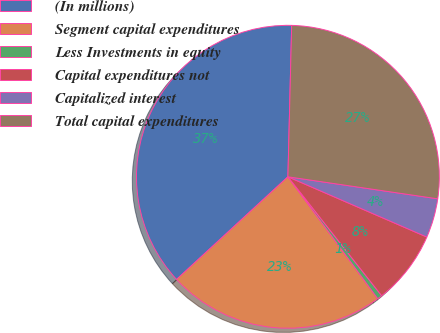Convert chart to OTSL. <chart><loc_0><loc_0><loc_500><loc_500><pie_chart><fcel>(In millions)<fcel>Segment capital expenditures<fcel>Less Investments in equity<fcel>Capital expenditures not<fcel>Capitalized interest<fcel>Total capital expenditures<nl><fcel>37.25%<fcel>23.25%<fcel>0.52%<fcel>7.86%<fcel>4.19%<fcel>26.93%<nl></chart> 